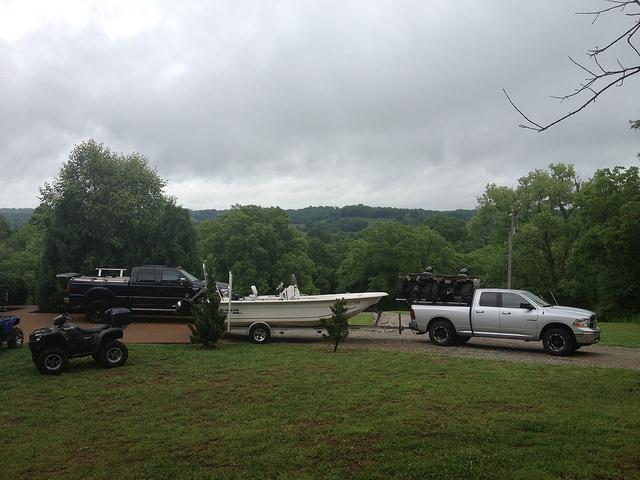Does it look like it might rain?
Write a very short answer. Yes. What activity is this vehicle typically used for?
Concise answer only. Driving. What is the vehicle in the picture?
Give a very brief answer. Truck. Is this truck in a parking lot?
Quick response, please. No. Is it sunny here?
Concise answer only. No. Is this a sunny day?
Answer briefly. No. Is this a civilian vehicle?
Answer briefly. Yes. Is it raining?
Short answer required. No. Is it a cloudy day?
Quick response, please. Yes. Is there a four-wheeler in this photo?
Answer briefly. Yes. Where is the house?
Short answer required. No house. What are the trucks behind?
Concise answer only. Boat. Overcast or sunny?
Concise answer only. Overcast. Does that truck get good gas mileage?
Concise answer only. No. 